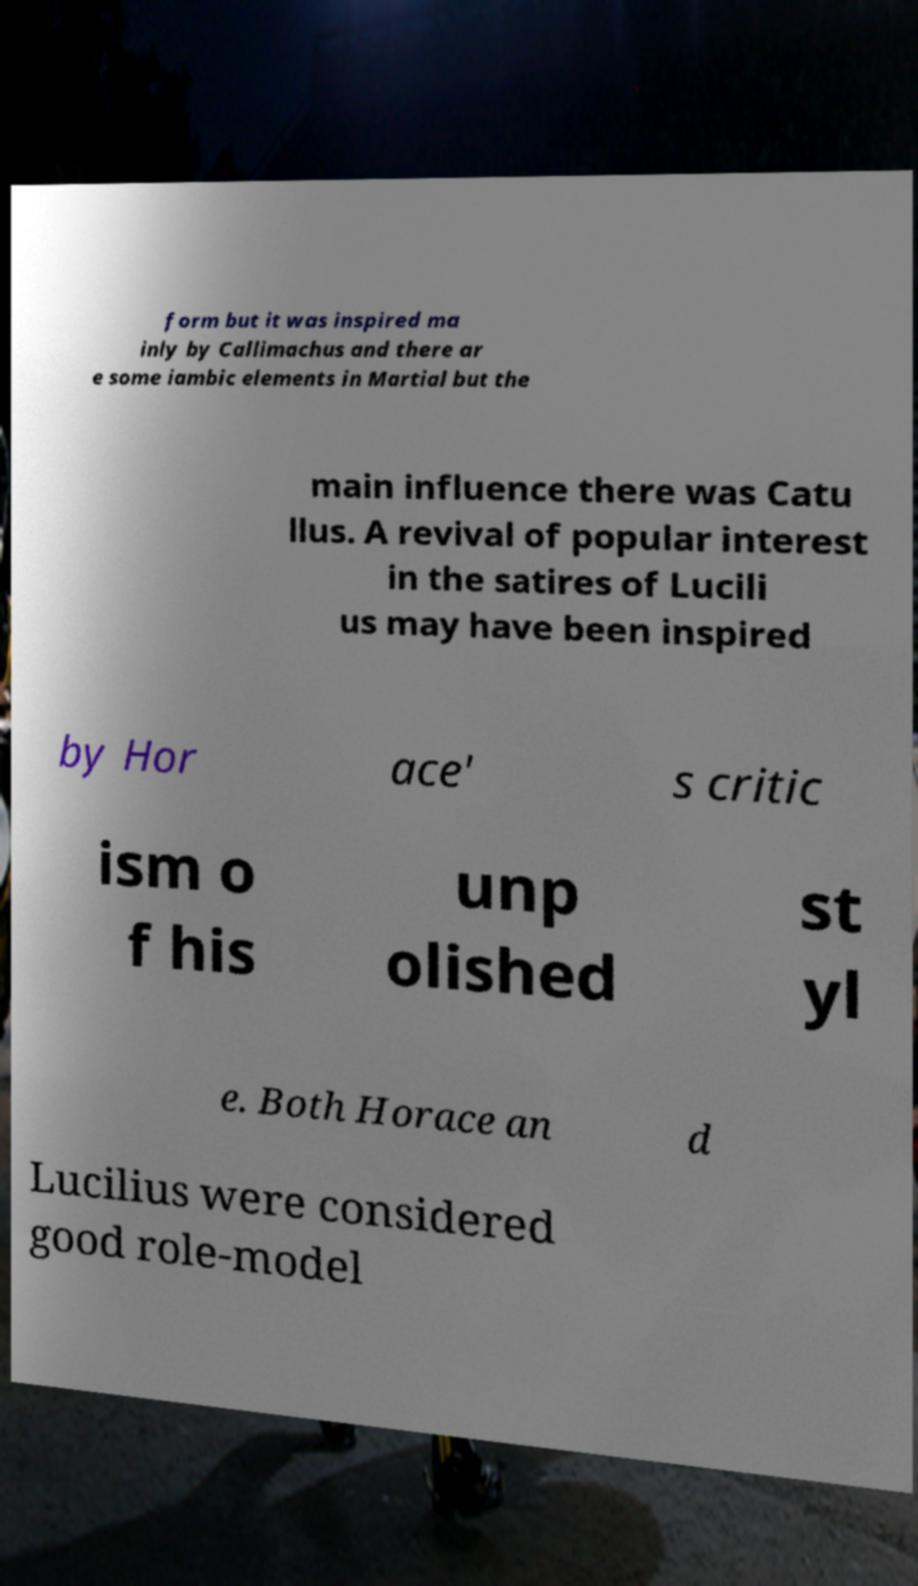There's text embedded in this image that I need extracted. Can you transcribe it verbatim? form but it was inspired ma inly by Callimachus and there ar e some iambic elements in Martial but the main influence there was Catu llus. A revival of popular interest in the satires of Lucili us may have been inspired by Hor ace' s critic ism o f his unp olished st yl e. Both Horace an d Lucilius were considered good role-model 